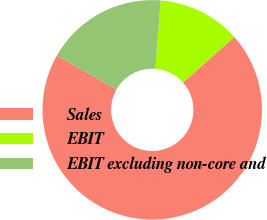Convert chart. <chart><loc_0><loc_0><loc_500><loc_500><pie_chart><fcel>Sales<fcel>EBIT<fcel>EBIT excluding non-core and<nl><fcel>69.79%<fcel>12.23%<fcel>17.98%<nl></chart> 